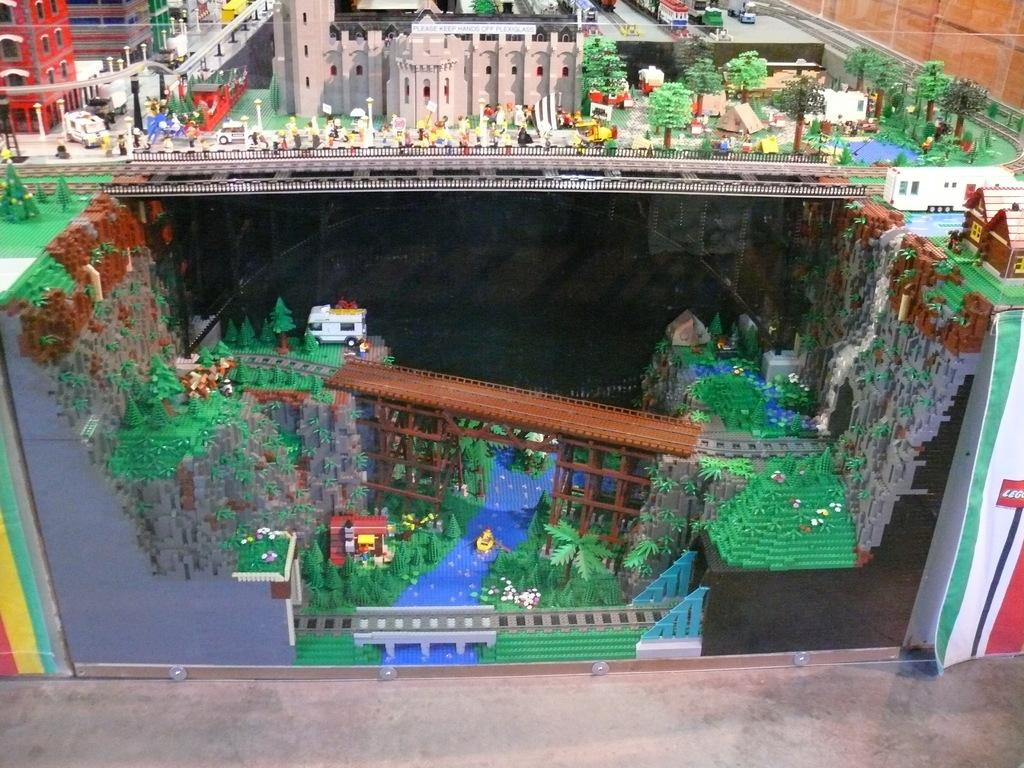What is the main subject of the image? The main subject of the image is a model of buildings. What other elements can be seen in the image? There are trees, a road, houses, and vehicles in the image. How many girls are seen taking a sail in the image? There are no girls or sailing activity depicted in the image. 